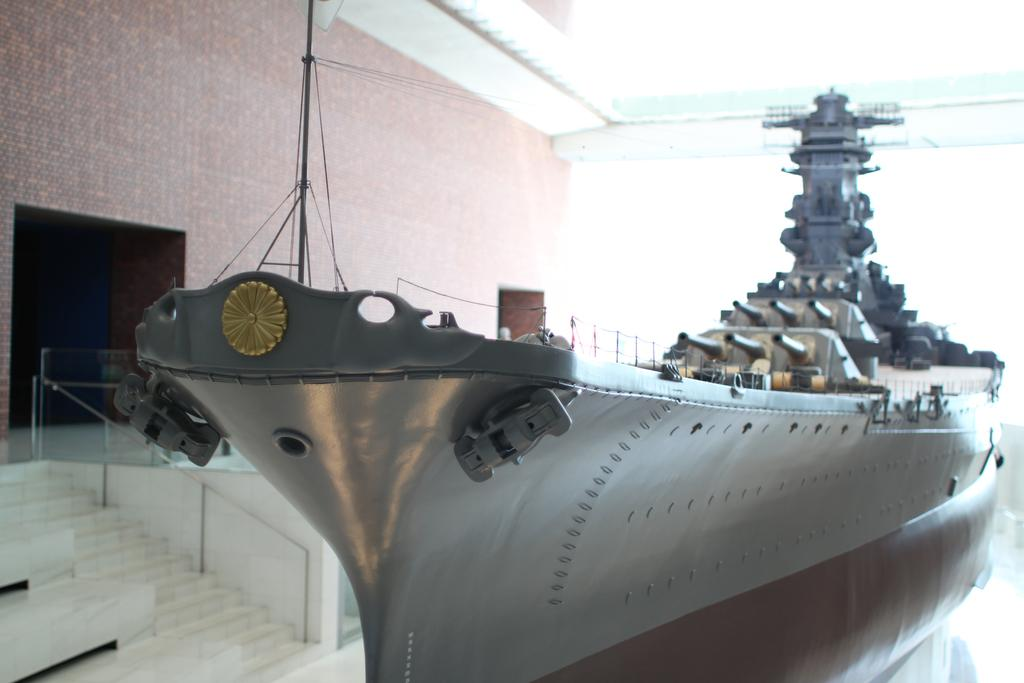What is the main subject of the image? The main subject of the image is a ship. What are some features of the ship? The ship has metal poles and cables. What can be seen on the left side of the image? There is a building, a staircase, and a railing on the left side of the image. What type of rhythm can be heard coming from the ship in the image? There is no sound or rhythm present in the image, as it is a still image of a ship. Can you tell me how many drawers are visible in the image? There are no drawers present in the image; it features a ship and objects on the left side of the image. 